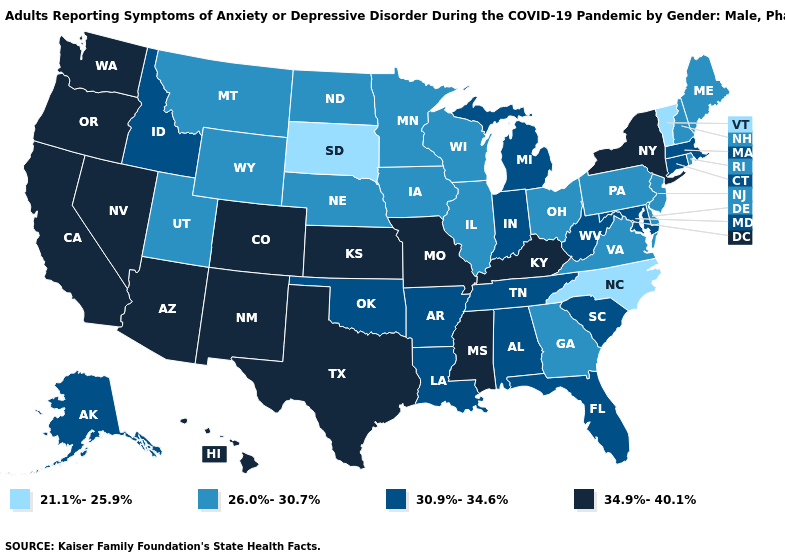Which states have the lowest value in the USA?
Short answer required. North Carolina, South Dakota, Vermont. How many symbols are there in the legend?
Quick response, please. 4. What is the value of Michigan?
Give a very brief answer. 30.9%-34.6%. Name the states that have a value in the range 30.9%-34.6%?
Answer briefly. Alabama, Alaska, Arkansas, Connecticut, Florida, Idaho, Indiana, Louisiana, Maryland, Massachusetts, Michigan, Oklahoma, South Carolina, Tennessee, West Virginia. What is the value of Virginia?
Quick response, please. 26.0%-30.7%. What is the lowest value in states that border Rhode Island?
Be succinct. 30.9%-34.6%. How many symbols are there in the legend?
Concise answer only. 4. Which states have the highest value in the USA?
Write a very short answer. Arizona, California, Colorado, Hawaii, Kansas, Kentucky, Mississippi, Missouri, Nevada, New Mexico, New York, Oregon, Texas, Washington. Name the states that have a value in the range 26.0%-30.7%?
Quick response, please. Delaware, Georgia, Illinois, Iowa, Maine, Minnesota, Montana, Nebraska, New Hampshire, New Jersey, North Dakota, Ohio, Pennsylvania, Rhode Island, Utah, Virginia, Wisconsin, Wyoming. Does Georgia have the highest value in the South?
Give a very brief answer. No. Does the map have missing data?
Keep it brief. No. What is the value of Oregon?
Write a very short answer. 34.9%-40.1%. Name the states that have a value in the range 30.9%-34.6%?
Quick response, please. Alabama, Alaska, Arkansas, Connecticut, Florida, Idaho, Indiana, Louisiana, Maryland, Massachusetts, Michigan, Oklahoma, South Carolina, Tennessee, West Virginia. Does Texas have the highest value in the South?
Give a very brief answer. Yes. What is the value of Nebraska?
Be succinct. 26.0%-30.7%. 